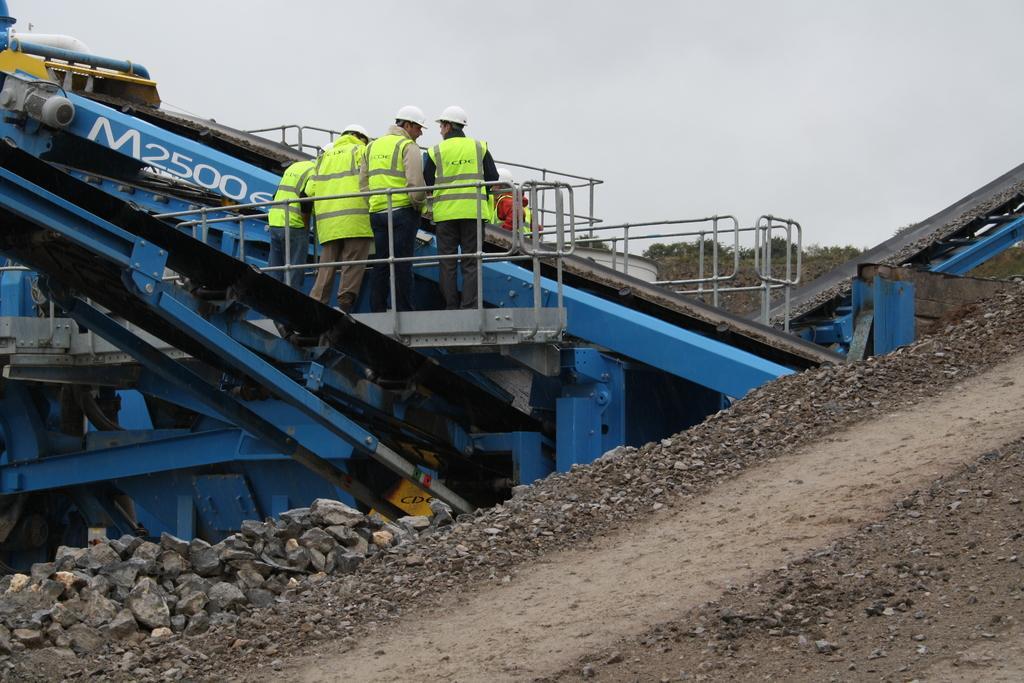Can you describe this image briefly? This image consists of many people wearing green jackets are standing on a machine. It looks like a bulldozer or a mining machine. At the bottom, there is ground along with rocks. To the top, there is sky. 